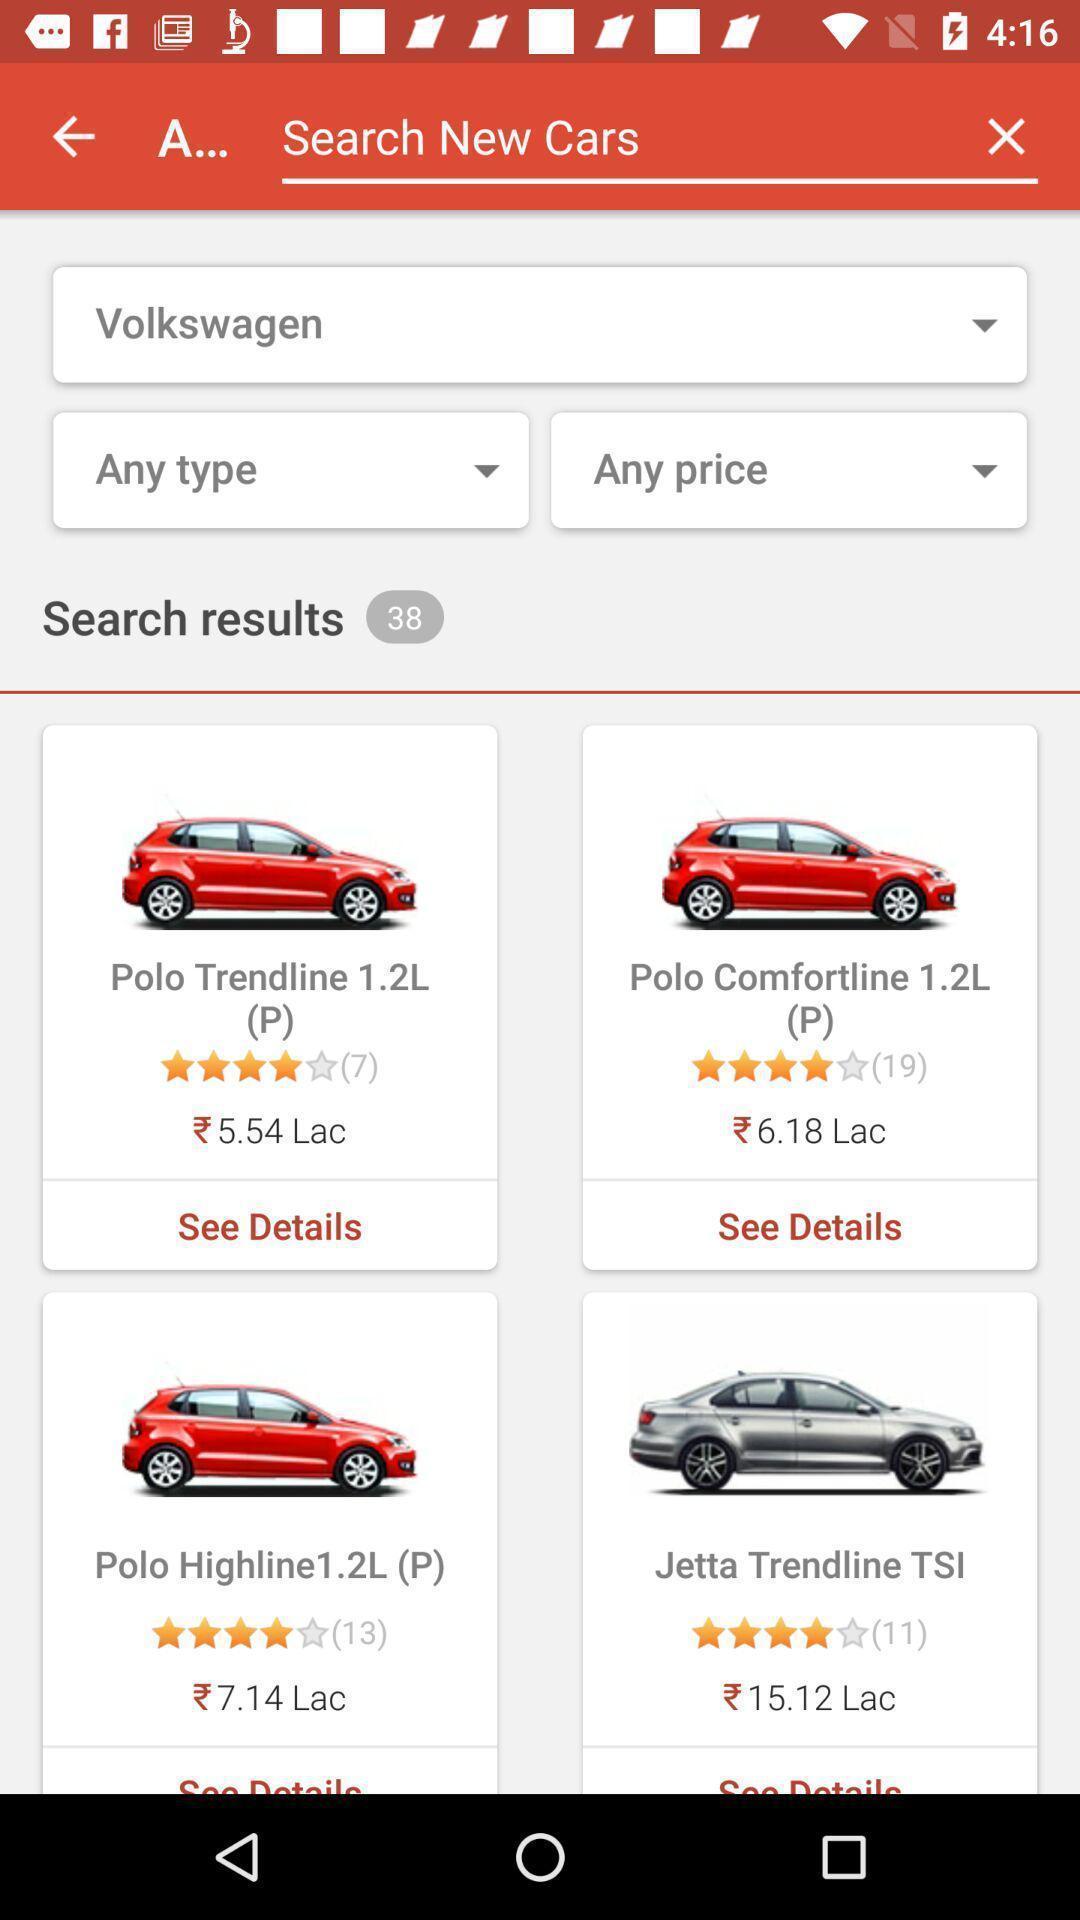Summarize the information in this screenshot. Search results of the car in the shopping app. 